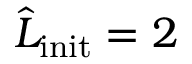<formula> <loc_0><loc_0><loc_500><loc_500>\widehat { L } _ { i n i t } = 2</formula> 